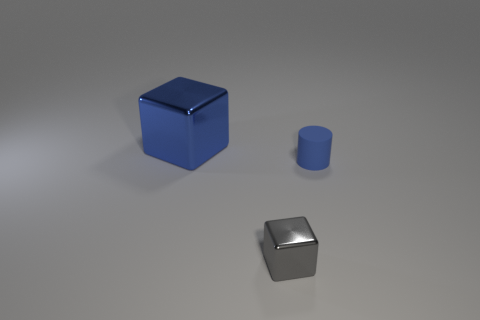Add 1 large brown rubber objects. How many objects exist? 4 Subtract all cylinders. How many objects are left? 2 Add 2 large shiny objects. How many large shiny objects exist? 3 Subtract 0 yellow blocks. How many objects are left? 3 Subtract all blue metallic blocks. Subtract all matte cylinders. How many objects are left? 1 Add 2 small gray metallic blocks. How many small gray metallic blocks are left? 3 